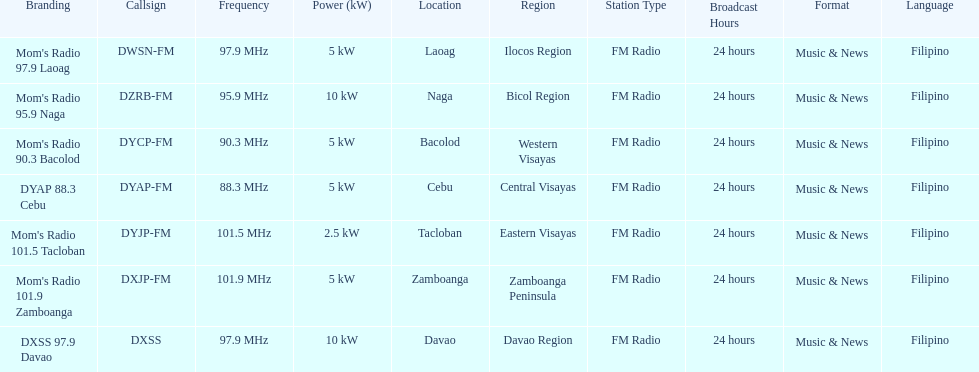What is the difference in kw between naga and bacolod radio? 5 kW. Would you be able to parse every entry in this table? {'header': ['Branding', 'Callsign', 'Frequency', 'Power (kW)', 'Location', 'Region', 'Station Type', 'Broadcast Hours', 'Format', 'Language'], 'rows': [["Mom's Radio 97.9 Laoag", 'DWSN-FM', '97.9\xa0MHz', '5\xa0kW', 'Laoag', 'Ilocos Region', 'FM Radio', '24 hours', 'Music & News', 'Filipino'], ["Mom's Radio 95.9 Naga", 'DZRB-FM', '95.9\xa0MHz', '10\xa0kW', 'Naga', 'Bicol Region', 'FM Radio', '24 hours', 'Music & News', 'Filipino'], ["Mom's Radio 90.3 Bacolod", 'DYCP-FM', '90.3\xa0MHz', '5\xa0kW', 'Bacolod', 'Western Visayas', 'FM Radio', '24 hours', 'Music & News', 'Filipino'], ['DYAP 88.3 Cebu', 'DYAP-FM', '88.3\xa0MHz', '5\xa0kW', 'Cebu', 'Central Visayas', 'FM Radio', '24 hours', 'Music & News', 'Filipino'], ["Mom's Radio 101.5 Tacloban", 'DYJP-FM', '101.5\xa0MHz', '2.5\xa0kW', 'Tacloban', 'Eastern Visayas', 'FM Radio', '24 hours', 'Music & News', 'Filipino'], ["Mom's Radio 101.9 Zamboanga", 'DXJP-FM', '101.9\xa0MHz', '5\xa0kW', 'Zamboanga', 'Zamboanga Peninsula', 'FM Radio', '24 hours', 'Music & News', 'Filipino'], ['DXSS 97.9 Davao', 'DXSS', '97.9\xa0MHz', '10\xa0kW', 'Davao', 'Davao Region', 'FM Radio', '24 hours', 'Music & News', 'Filipino']]} 